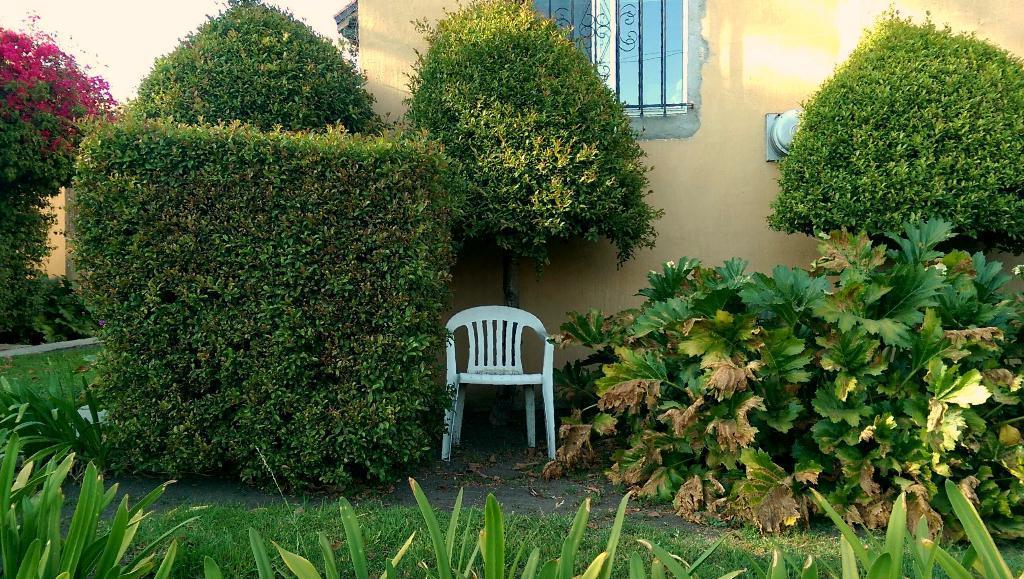In one or two sentences, can you explain what this image depicts? In this image in the front there are plants in the center. There is grass on the ground. In the background there are plants and there is an empty chair which is white in colour and there is a building and on the wall of the building there is an object which is grey in colour and there is a window. 